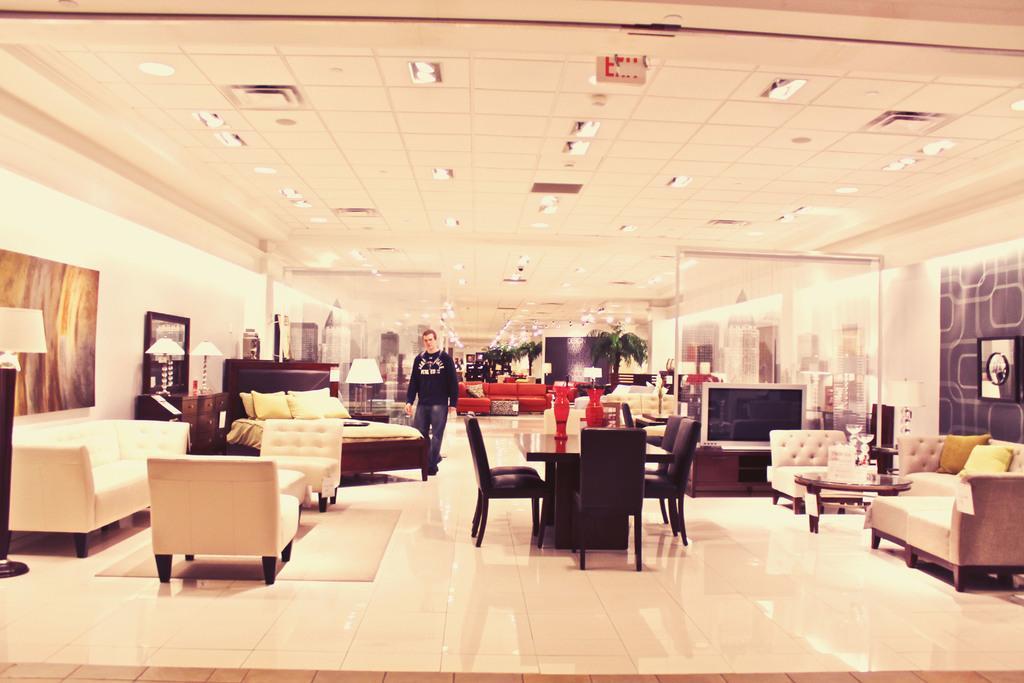Describe this image in one or two sentences. In the image we can see there is a man who is standing and there are beds, sofa, chairs, dining table, tv and trees in the house 